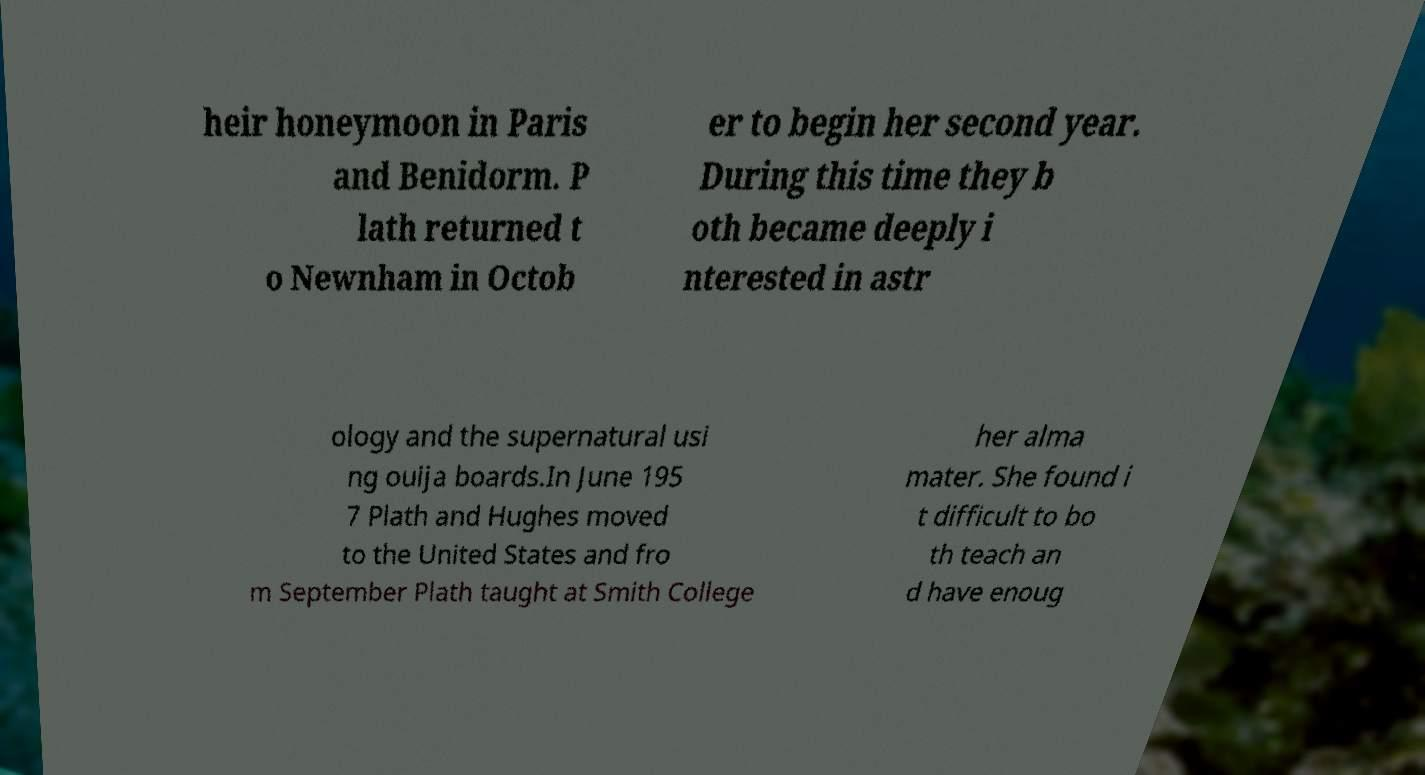Please identify and transcribe the text found in this image. heir honeymoon in Paris and Benidorm. P lath returned t o Newnham in Octob er to begin her second year. During this time they b oth became deeply i nterested in astr ology and the supernatural usi ng ouija boards.In June 195 7 Plath and Hughes moved to the United States and fro m September Plath taught at Smith College her alma mater. She found i t difficult to bo th teach an d have enoug 